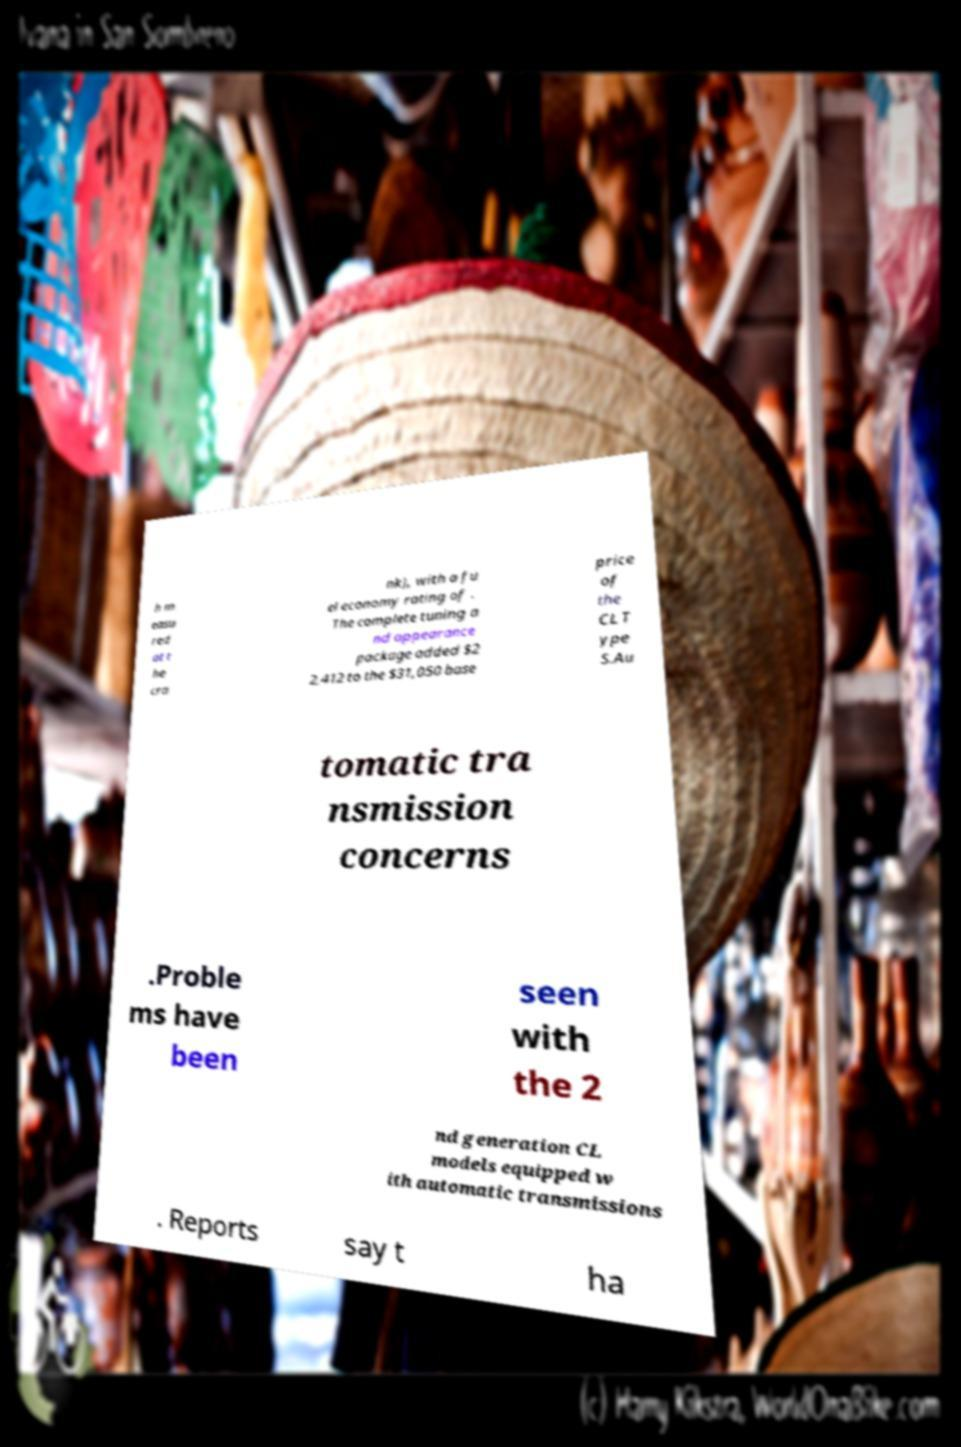Could you assist in decoding the text presented in this image and type it out clearly? h m easu red at t he cra nk), with a fu el economy rating of . The complete tuning a nd appearance package added $2 2,412 to the $31,050 base price of the CL T ype S.Au tomatic tra nsmission concerns .Proble ms have been seen with the 2 nd generation CL models equipped w ith automatic transmissions . Reports say t ha 